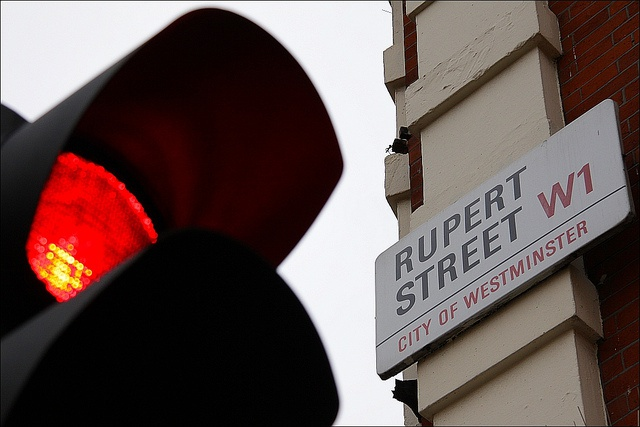Describe the objects in this image and their specific colors. I can see a traffic light in black, red, brown, and maroon tones in this image. 